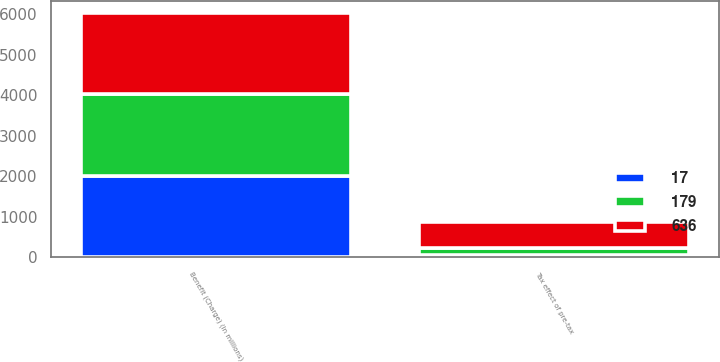<chart> <loc_0><loc_0><loc_500><loc_500><stacked_bar_chart><ecel><fcel>Benefit (Charge) (In millions)<fcel>Tax effect of pre-tax<nl><fcel>179<fcel>2013<fcel>179<nl><fcel>636<fcel>2012<fcel>636<nl><fcel>17<fcel>2011<fcel>50<nl></chart> 